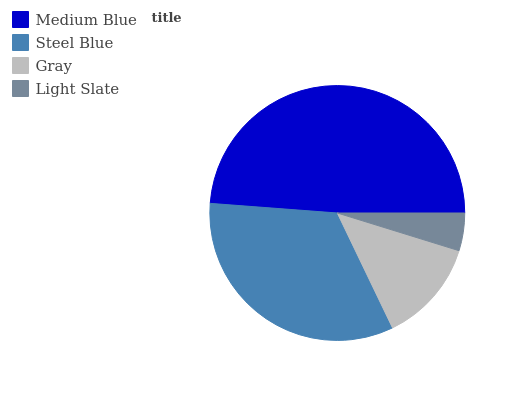Is Light Slate the minimum?
Answer yes or no. Yes. Is Medium Blue the maximum?
Answer yes or no. Yes. Is Steel Blue the minimum?
Answer yes or no. No. Is Steel Blue the maximum?
Answer yes or no. No. Is Medium Blue greater than Steel Blue?
Answer yes or no. Yes. Is Steel Blue less than Medium Blue?
Answer yes or no. Yes. Is Steel Blue greater than Medium Blue?
Answer yes or no. No. Is Medium Blue less than Steel Blue?
Answer yes or no. No. Is Steel Blue the high median?
Answer yes or no. Yes. Is Gray the low median?
Answer yes or no. Yes. Is Light Slate the high median?
Answer yes or no. No. Is Medium Blue the low median?
Answer yes or no. No. 